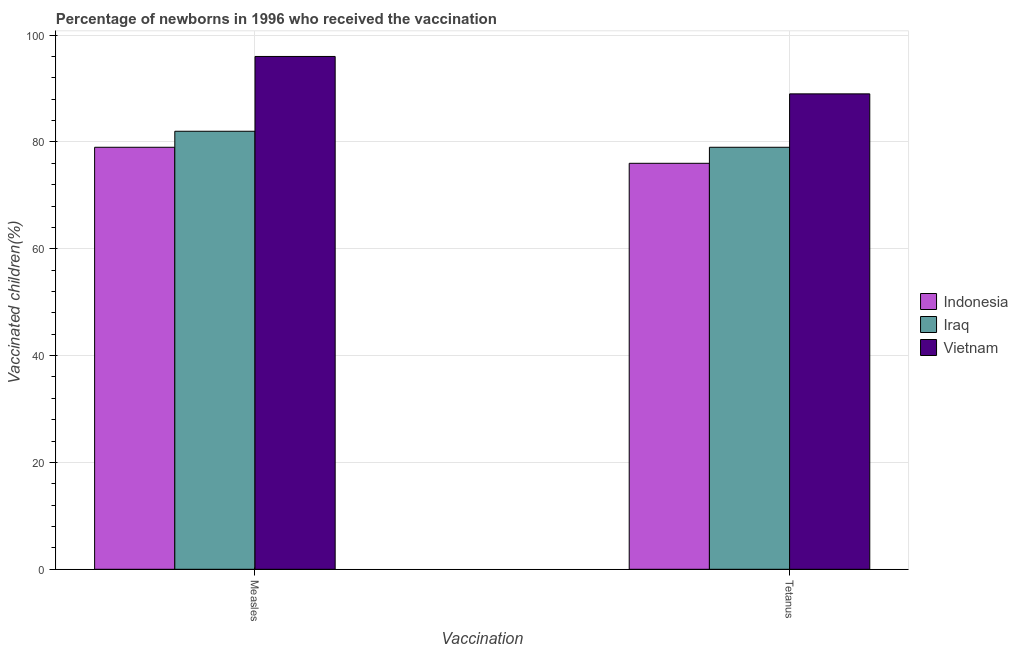How many different coloured bars are there?
Make the answer very short. 3. Are the number of bars on each tick of the X-axis equal?
Provide a short and direct response. Yes. What is the label of the 1st group of bars from the left?
Provide a succinct answer. Measles. What is the percentage of newborns who received vaccination for tetanus in Vietnam?
Provide a succinct answer. 89. Across all countries, what is the maximum percentage of newborns who received vaccination for measles?
Offer a very short reply. 96. Across all countries, what is the minimum percentage of newborns who received vaccination for measles?
Your answer should be very brief. 79. In which country was the percentage of newborns who received vaccination for measles maximum?
Provide a short and direct response. Vietnam. What is the total percentage of newborns who received vaccination for tetanus in the graph?
Your response must be concise. 244. What is the difference between the percentage of newborns who received vaccination for measles in Indonesia and that in Iraq?
Give a very brief answer. -3. What is the difference between the percentage of newborns who received vaccination for tetanus in Iraq and the percentage of newborns who received vaccination for measles in Indonesia?
Offer a terse response. 0. What is the average percentage of newborns who received vaccination for measles per country?
Make the answer very short. 85.67. What is the difference between the percentage of newborns who received vaccination for tetanus and percentage of newborns who received vaccination for measles in Iraq?
Your answer should be very brief. -3. What is the ratio of the percentage of newborns who received vaccination for measles in Vietnam to that in Iraq?
Offer a terse response. 1.17. Is the percentage of newborns who received vaccination for measles in Indonesia less than that in Iraq?
Keep it short and to the point. Yes. What does the 2nd bar from the left in Tetanus represents?
Give a very brief answer. Iraq. What does the 2nd bar from the right in Tetanus represents?
Provide a short and direct response. Iraq. How many bars are there?
Give a very brief answer. 6. Are all the bars in the graph horizontal?
Keep it short and to the point. No. What is the difference between two consecutive major ticks on the Y-axis?
Offer a terse response. 20. Where does the legend appear in the graph?
Provide a short and direct response. Center right. What is the title of the graph?
Keep it short and to the point. Percentage of newborns in 1996 who received the vaccination. Does "France" appear as one of the legend labels in the graph?
Ensure brevity in your answer.  No. What is the label or title of the X-axis?
Provide a succinct answer. Vaccination. What is the label or title of the Y-axis?
Provide a succinct answer. Vaccinated children(%)
. What is the Vaccinated children(%)
 in Indonesia in Measles?
Your answer should be very brief. 79. What is the Vaccinated children(%)
 in Iraq in Measles?
Keep it short and to the point. 82. What is the Vaccinated children(%)
 in Vietnam in Measles?
Offer a very short reply. 96. What is the Vaccinated children(%)
 in Indonesia in Tetanus?
Offer a terse response. 76. What is the Vaccinated children(%)
 in Iraq in Tetanus?
Offer a terse response. 79. What is the Vaccinated children(%)
 of Vietnam in Tetanus?
Keep it short and to the point. 89. Across all Vaccination, what is the maximum Vaccinated children(%)
 of Indonesia?
Make the answer very short. 79. Across all Vaccination, what is the maximum Vaccinated children(%)
 of Iraq?
Provide a short and direct response. 82. Across all Vaccination, what is the maximum Vaccinated children(%)
 in Vietnam?
Your response must be concise. 96. Across all Vaccination, what is the minimum Vaccinated children(%)
 in Iraq?
Your answer should be very brief. 79. Across all Vaccination, what is the minimum Vaccinated children(%)
 of Vietnam?
Make the answer very short. 89. What is the total Vaccinated children(%)
 of Indonesia in the graph?
Make the answer very short. 155. What is the total Vaccinated children(%)
 in Iraq in the graph?
Your answer should be compact. 161. What is the total Vaccinated children(%)
 of Vietnam in the graph?
Your answer should be very brief. 185. What is the difference between the Vaccinated children(%)
 in Indonesia in Measles and that in Tetanus?
Offer a terse response. 3. What is the difference between the Vaccinated children(%)
 of Vietnam in Measles and that in Tetanus?
Your answer should be compact. 7. What is the difference between the Vaccinated children(%)
 of Indonesia in Measles and the Vaccinated children(%)
 of Iraq in Tetanus?
Offer a terse response. 0. What is the difference between the Vaccinated children(%)
 in Indonesia in Measles and the Vaccinated children(%)
 in Vietnam in Tetanus?
Provide a succinct answer. -10. What is the average Vaccinated children(%)
 in Indonesia per Vaccination?
Provide a short and direct response. 77.5. What is the average Vaccinated children(%)
 in Iraq per Vaccination?
Ensure brevity in your answer.  80.5. What is the average Vaccinated children(%)
 in Vietnam per Vaccination?
Provide a short and direct response. 92.5. What is the difference between the Vaccinated children(%)
 in Indonesia and Vaccinated children(%)
 in Iraq in Measles?
Keep it short and to the point. -3. What is the difference between the Vaccinated children(%)
 of Indonesia and Vaccinated children(%)
 of Vietnam in Measles?
Your answer should be very brief. -17. What is the difference between the Vaccinated children(%)
 in Indonesia and Vaccinated children(%)
 in Vietnam in Tetanus?
Offer a terse response. -13. What is the difference between the Vaccinated children(%)
 in Iraq and Vaccinated children(%)
 in Vietnam in Tetanus?
Offer a very short reply. -10. What is the ratio of the Vaccinated children(%)
 of Indonesia in Measles to that in Tetanus?
Offer a very short reply. 1.04. What is the ratio of the Vaccinated children(%)
 in Iraq in Measles to that in Tetanus?
Offer a terse response. 1.04. What is the ratio of the Vaccinated children(%)
 in Vietnam in Measles to that in Tetanus?
Your response must be concise. 1.08. What is the difference between the highest and the second highest Vaccinated children(%)
 of Vietnam?
Keep it short and to the point. 7. What is the difference between the highest and the lowest Vaccinated children(%)
 in Indonesia?
Provide a short and direct response. 3. 